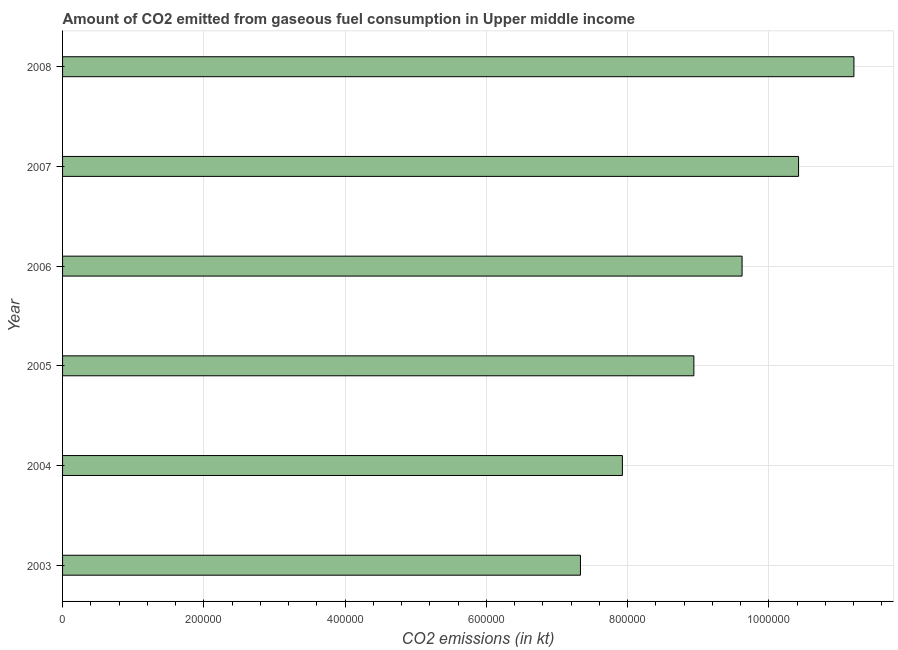What is the title of the graph?
Your response must be concise. Amount of CO2 emitted from gaseous fuel consumption in Upper middle income. What is the label or title of the X-axis?
Give a very brief answer. CO2 emissions (in kt). What is the co2 emissions from gaseous fuel consumption in 2008?
Your answer should be compact. 1.12e+06. Across all years, what is the maximum co2 emissions from gaseous fuel consumption?
Your response must be concise. 1.12e+06. Across all years, what is the minimum co2 emissions from gaseous fuel consumption?
Offer a terse response. 7.33e+05. In which year was the co2 emissions from gaseous fuel consumption minimum?
Offer a very short reply. 2003. What is the sum of the co2 emissions from gaseous fuel consumption?
Your response must be concise. 5.54e+06. What is the difference between the co2 emissions from gaseous fuel consumption in 2005 and 2007?
Give a very brief answer. -1.48e+05. What is the average co2 emissions from gaseous fuel consumption per year?
Offer a very short reply. 9.24e+05. What is the median co2 emissions from gaseous fuel consumption?
Provide a succinct answer. 9.28e+05. What is the ratio of the co2 emissions from gaseous fuel consumption in 2006 to that in 2008?
Ensure brevity in your answer.  0.86. Is the co2 emissions from gaseous fuel consumption in 2005 less than that in 2006?
Your response must be concise. Yes. What is the difference between the highest and the second highest co2 emissions from gaseous fuel consumption?
Offer a terse response. 7.84e+04. Is the sum of the co2 emissions from gaseous fuel consumption in 2005 and 2006 greater than the maximum co2 emissions from gaseous fuel consumption across all years?
Ensure brevity in your answer.  Yes. What is the difference between the highest and the lowest co2 emissions from gaseous fuel consumption?
Your answer should be very brief. 3.87e+05. How many bars are there?
Provide a short and direct response. 6. How many years are there in the graph?
Offer a terse response. 6. Are the values on the major ticks of X-axis written in scientific E-notation?
Your answer should be compact. No. What is the CO2 emissions (in kt) in 2003?
Give a very brief answer. 7.33e+05. What is the CO2 emissions (in kt) in 2004?
Offer a terse response. 7.93e+05. What is the CO2 emissions (in kt) in 2005?
Offer a terse response. 8.94e+05. What is the CO2 emissions (in kt) of 2006?
Provide a succinct answer. 9.62e+05. What is the CO2 emissions (in kt) in 2007?
Your answer should be very brief. 1.04e+06. What is the CO2 emissions (in kt) in 2008?
Make the answer very short. 1.12e+06. What is the difference between the CO2 emissions (in kt) in 2003 and 2004?
Offer a terse response. -5.94e+04. What is the difference between the CO2 emissions (in kt) in 2003 and 2005?
Give a very brief answer. -1.61e+05. What is the difference between the CO2 emissions (in kt) in 2003 and 2006?
Your answer should be compact. -2.29e+05. What is the difference between the CO2 emissions (in kt) in 2003 and 2007?
Offer a very short reply. -3.09e+05. What is the difference between the CO2 emissions (in kt) in 2003 and 2008?
Keep it short and to the point. -3.87e+05. What is the difference between the CO2 emissions (in kt) in 2004 and 2005?
Offer a very short reply. -1.01e+05. What is the difference between the CO2 emissions (in kt) in 2004 and 2006?
Ensure brevity in your answer.  -1.69e+05. What is the difference between the CO2 emissions (in kt) in 2004 and 2007?
Provide a short and direct response. -2.49e+05. What is the difference between the CO2 emissions (in kt) in 2004 and 2008?
Provide a succinct answer. -3.28e+05. What is the difference between the CO2 emissions (in kt) in 2005 and 2006?
Provide a short and direct response. -6.83e+04. What is the difference between the CO2 emissions (in kt) in 2005 and 2007?
Ensure brevity in your answer.  -1.48e+05. What is the difference between the CO2 emissions (in kt) in 2005 and 2008?
Your answer should be very brief. -2.27e+05. What is the difference between the CO2 emissions (in kt) in 2006 and 2007?
Offer a very short reply. -8.00e+04. What is the difference between the CO2 emissions (in kt) in 2006 and 2008?
Keep it short and to the point. -1.58e+05. What is the difference between the CO2 emissions (in kt) in 2007 and 2008?
Offer a terse response. -7.84e+04. What is the ratio of the CO2 emissions (in kt) in 2003 to that in 2004?
Offer a terse response. 0.93. What is the ratio of the CO2 emissions (in kt) in 2003 to that in 2005?
Provide a succinct answer. 0.82. What is the ratio of the CO2 emissions (in kt) in 2003 to that in 2006?
Ensure brevity in your answer.  0.76. What is the ratio of the CO2 emissions (in kt) in 2003 to that in 2007?
Offer a very short reply. 0.7. What is the ratio of the CO2 emissions (in kt) in 2003 to that in 2008?
Ensure brevity in your answer.  0.65. What is the ratio of the CO2 emissions (in kt) in 2004 to that in 2005?
Give a very brief answer. 0.89. What is the ratio of the CO2 emissions (in kt) in 2004 to that in 2006?
Your response must be concise. 0.82. What is the ratio of the CO2 emissions (in kt) in 2004 to that in 2007?
Make the answer very short. 0.76. What is the ratio of the CO2 emissions (in kt) in 2004 to that in 2008?
Your answer should be compact. 0.71. What is the ratio of the CO2 emissions (in kt) in 2005 to that in 2006?
Give a very brief answer. 0.93. What is the ratio of the CO2 emissions (in kt) in 2005 to that in 2007?
Provide a succinct answer. 0.86. What is the ratio of the CO2 emissions (in kt) in 2005 to that in 2008?
Ensure brevity in your answer.  0.8. What is the ratio of the CO2 emissions (in kt) in 2006 to that in 2007?
Provide a succinct answer. 0.92. What is the ratio of the CO2 emissions (in kt) in 2006 to that in 2008?
Your answer should be very brief. 0.86. What is the ratio of the CO2 emissions (in kt) in 2007 to that in 2008?
Provide a short and direct response. 0.93. 